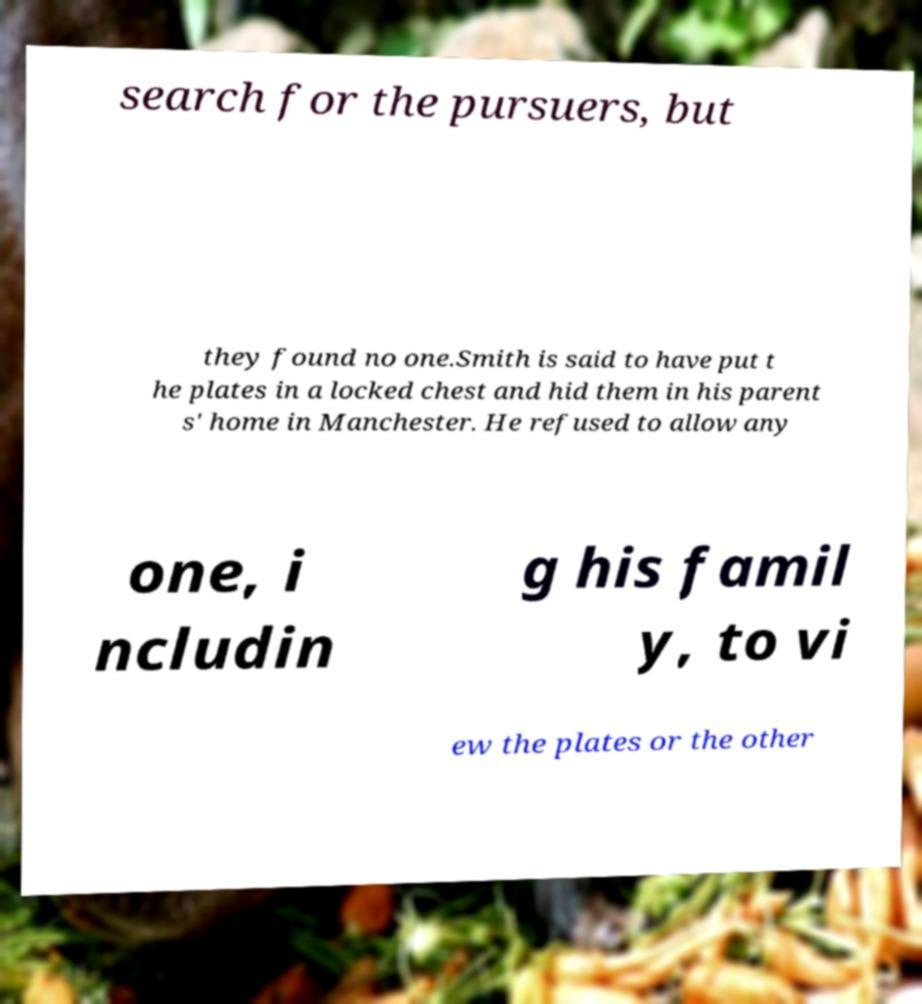There's text embedded in this image that I need extracted. Can you transcribe it verbatim? search for the pursuers, but they found no one.Smith is said to have put t he plates in a locked chest and hid them in his parent s' home in Manchester. He refused to allow any one, i ncludin g his famil y, to vi ew the plates or the other 